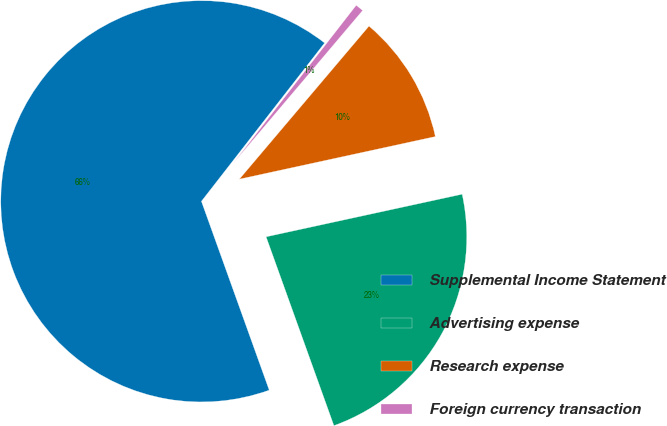Convert chart to OTSL. <chart><loc_0><loc_0><loc_500><loc_500><pie_chart><fcel>Supplemental Income Statement<fcel>Advertising expense<fcel>Research expense<fcel>Foreign currency transaction<nl><fcel>66.01%<fcel>22.92%<fcel>10.41%<fcel>0.66%<nl></chart> 